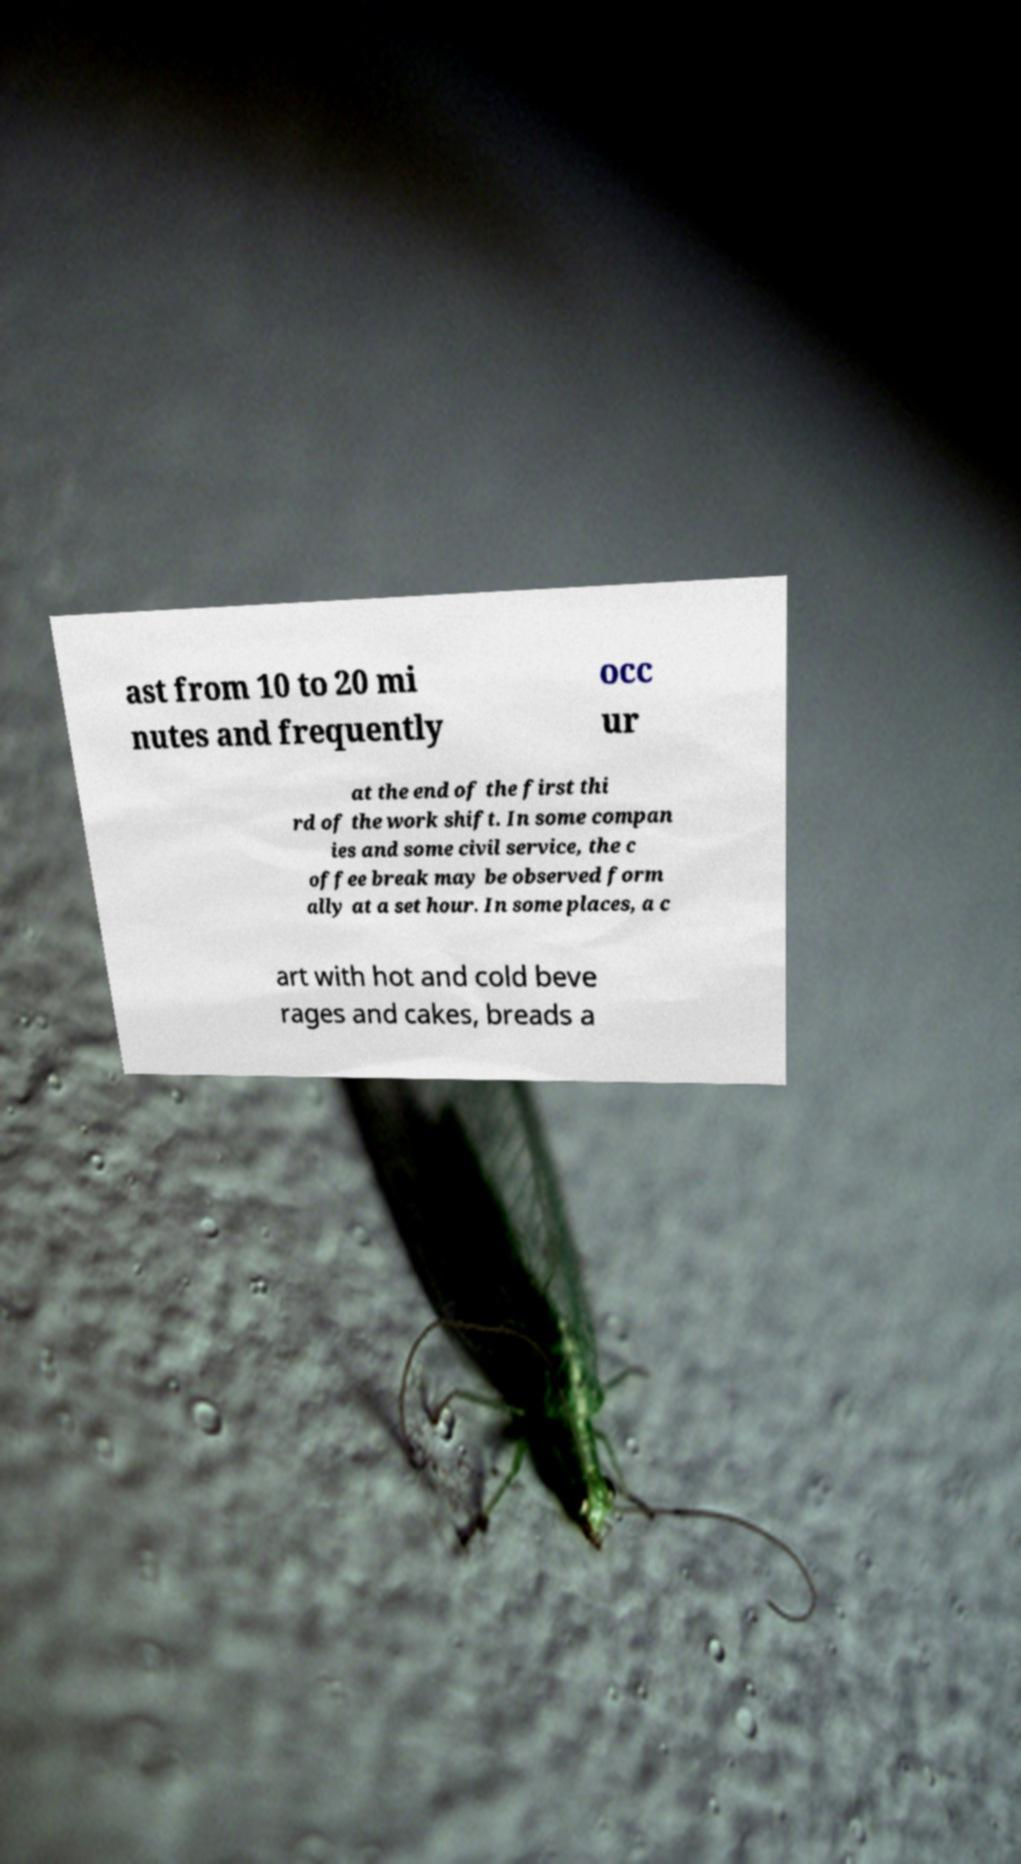Please identify and transcribe the text found in this image. ast from 10 to 20 mi nutes and frequently occ ur at the end of the first thi rd of the work shift. In some compan ies and some civil service, the c offee break may be observed form ally at a set hour. In some places, a c art with hot and cold beve rages and cakes, breads a 